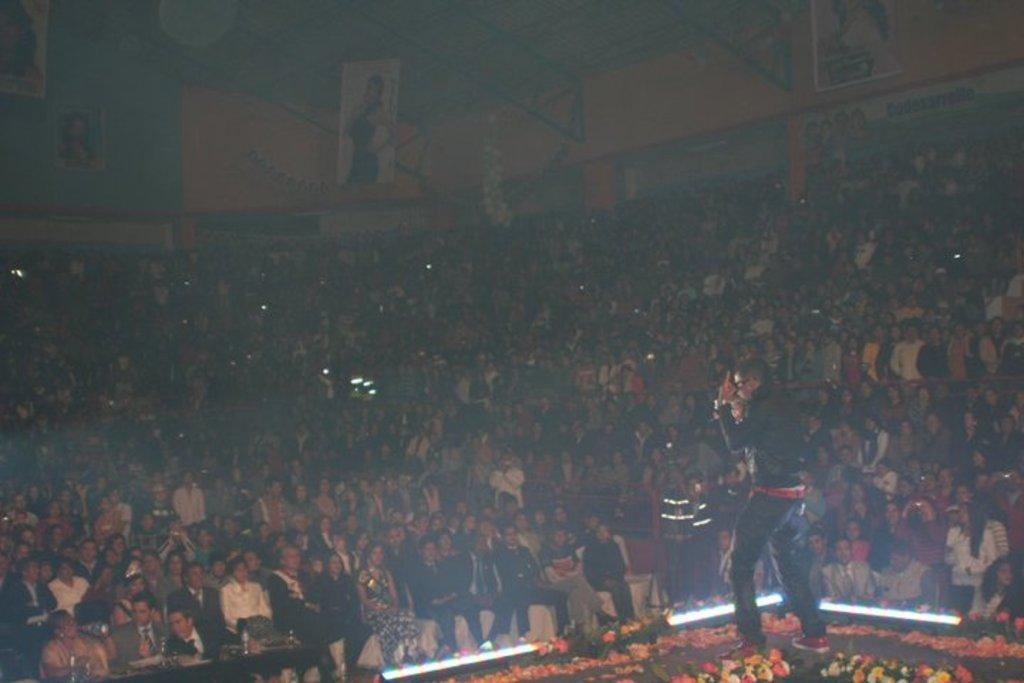In one or two sentences, can you explain what this image depicts? In this image a person is standing on the stage having few flowers. Before him there are few persons sitting on the chairs. Background there is a wall having few posts attached to it. 